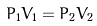<formula> <loc_0><loc_0><loc_500><loc_500>P _ { 1 } V _ { 1 } = P _ { 2 } V _ { 2 }</formula> 